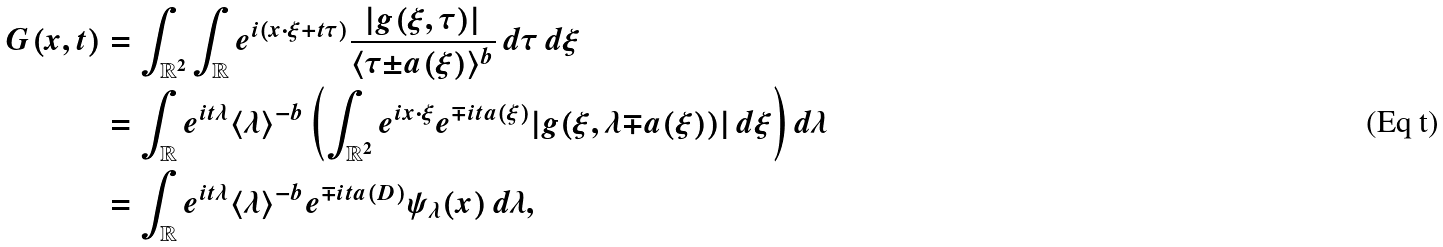Convert formula to latex. <formula><loc_0><loc_0><loc_500><loc_500>G ( x , t ) & = \int _ { \mathbb { R } ^ { 2 } } \int _ { \mathbb { R } } e ^ { i ( x \cdot \xi + t \tau ) } \frac { | { g ( \xi , \tau ) } | } { \langle \tau { \pm } a ( \xi ) \rangle ^ { b } } \, d \tau \, d \xi \\ & = \int _ { \mathbb { R } } e ^ { i t \lambda } \langle \lambda \rangle ^ { - b } \left ( \int _ { \mathbb { R } ^ { 2 } } e ^ { i x \cdot \xi } e ^ { { \mp } i t a ( \xi ) } | { g ( \xi , \lambda { \mp } a ( \xi ) ) } | \, d \xi \right ) d \lambda \\ & = \int _ { \mathbb { R } } e ^ { i t \lambda } \langle \lambda \rangle ^ { - b } e ^ { { \mp } i t a ( D ) } \psi _ { \lambda } ( x ) \, d \lambda ,</formula> 